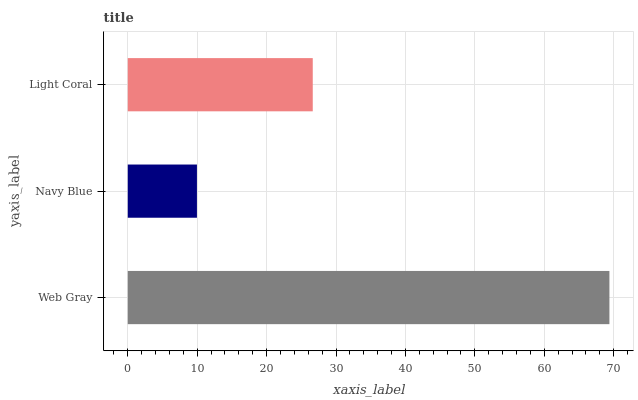Is Navy Blue the minimum?
Answer yes or no. Yes. Is Web Gray the maximum?
Answer yes or no. Yes. Is Light Coral the minimum?
Answer yes or no. No. Is Light Coral the maximum?
Answer yes or no. No. Is Light Coral greater than Navy Blue?
Answer yes or no. Yes. Is Navy Blue less than Light Coral?
Answer yes or no. Yes. Is Navy Blue greater than Light Coral?
Answer yes or no. No. Is Light Coral less than Navy Blue?
Answer yes or no. No. Is Light Coral the high median?
Answer yes or no. Yes. Is Light Coral the low median?
Answer yes or no. Yes. Is Navy Blue the high median?
Answer yes or no. No. Is Web Gray the low median?
Answer yes or no. No. 